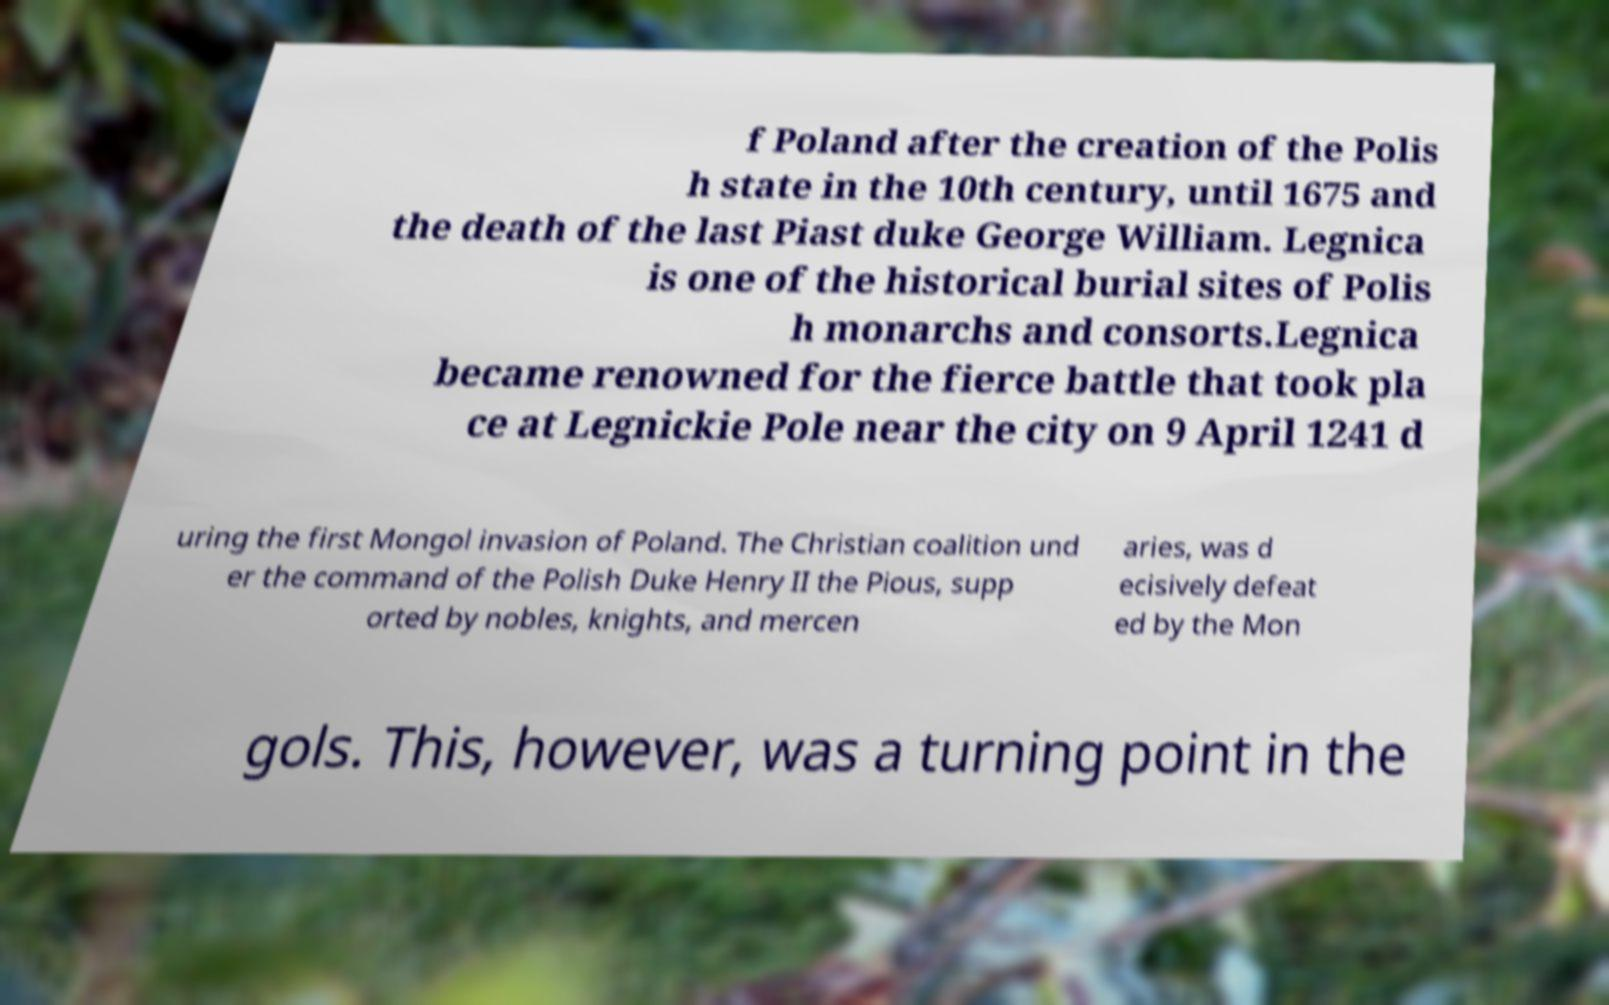Could you assist in decoding the text presented in this image and type it out clearly? f Poland after the creation of the Polis h state in the 10th century, until 1675 and the death of the last Piast duke George William. Legnica is one of the historical burial sites of Polis h monarchs and consorts.Legnica became renowned for the fierce battle that took pla ce at Legnickie Pole near the city on 9 April 1241 d uring the first Mongol invasion of Poland. The Christian coalition und er the command of the Polish Duke Henry II the Pious, supp orted by nobles, knights, and mercen aries, was d ecisively defeat ed by the Mon gols. This, however, was a turning point in the 